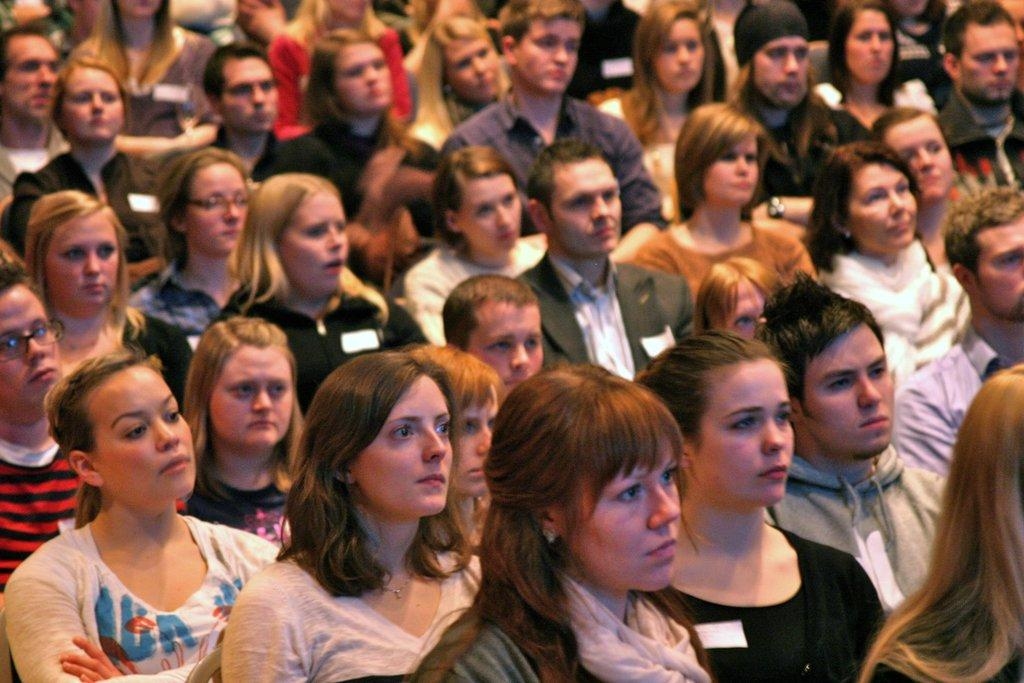Who is present in the image? There are people in the image. What are the people doing in the image? The people are seated. How many legs does the uncle have in the image? There is no uncle present in the image, and therefore no legs to count. 